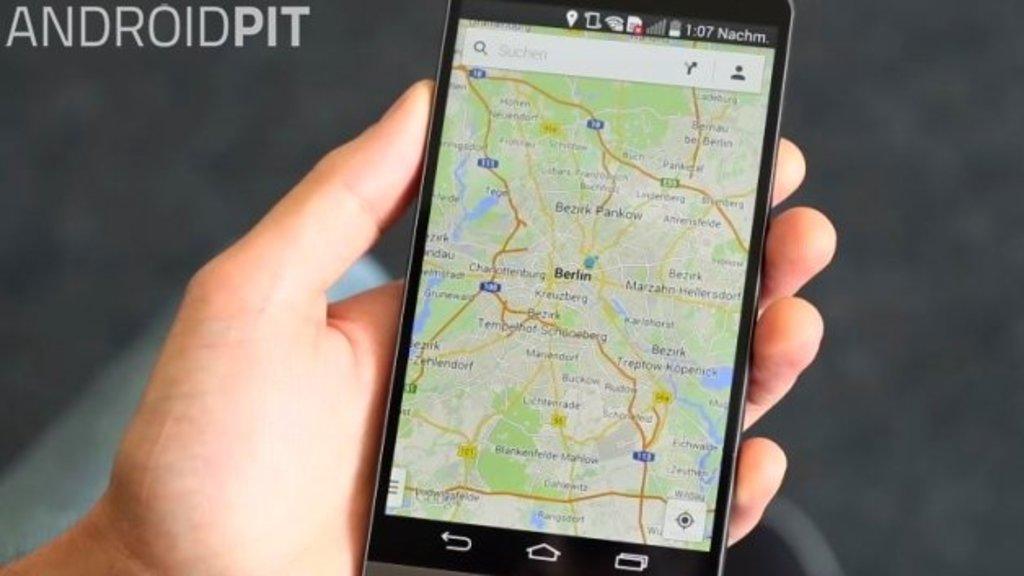What brand is advertised in this picture?
Your response must be concise. Androidpit. What city map is that?
Offer a very short reply. Berlin. 